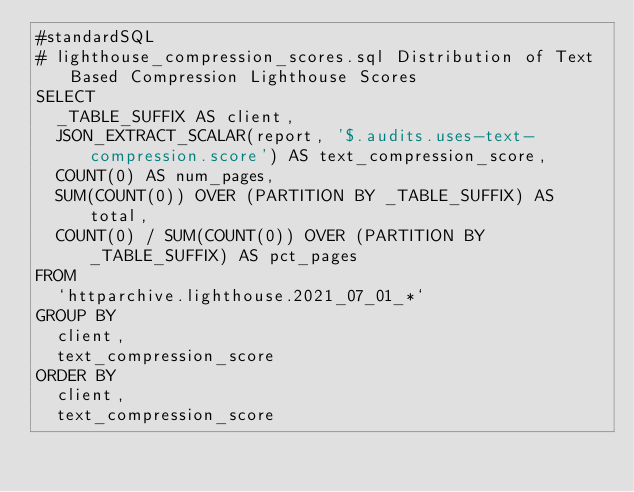<code> <loc_0><loc_0><loc_500><loc_500><_SQL_>#standardSQL
# lighthouse_compression_scores.sql Distribution of Text Based Compression Lighthouse Scores
SELECT
  _TABLE_SUFFIX AS client,
  JSON_EXTRACT_SCALAR(report, '$.audits.uses-text-compression.score') AS text_compression_score,
  COUNT(0) AS num_pages,
  SUM(COUNT(0)) OVER (PARTITION BY _TABLE_SUFFIX) AS total,
  COUNT(0) / SUM(COUNT(0)) OVER (PARTITION BY _TABLE_SUFFIX) AS pct_pages
FROM
  `httparchive.lighthouse.2021_07_01_*`
GROUP BY
  client,
  text_compression_score
ORDER BY
  client,
  text_compression_score
</code> 